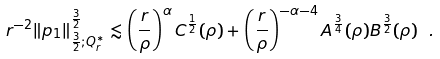Convert formula to latex. <formula><loc_0><loc_0><loc_500><loc_500>r ^ { - 2 } \| p _ { 1 } \| _ { \frac { 3 } { 2 } ; Q _ { r } ^ { * } } ^ { \frac { 3 } { 2 } } \lesssim \left ( \frac { r } { \rho } \right ) ^ { \alpha } C ^ { \frac { 1 } { 2 } } ( \rho ) + \left ( \frac { r } { \rho } \right ) ^ { - \alpha - 4 } A ^ { \frac { 3 } { 4 } } ( \rho ) B ^ { \frac { 3 } { 2 } } ( \rho ) \ .</formula> 